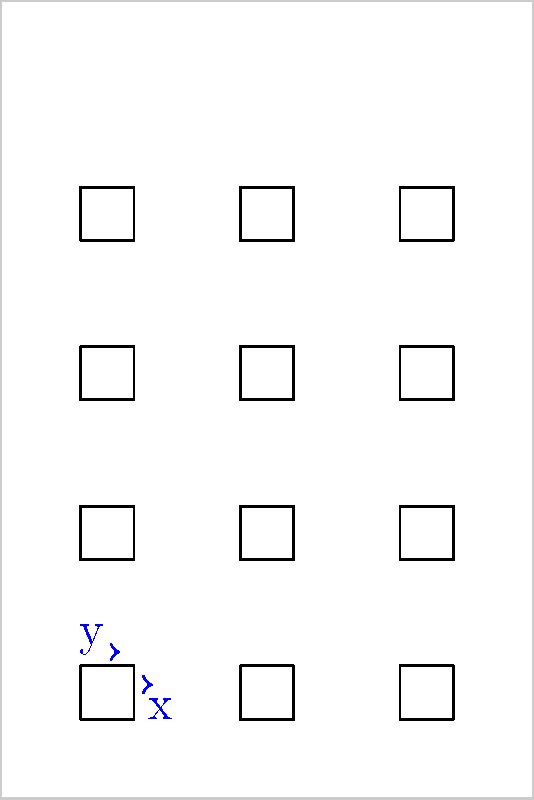A standard sheet measures 10 inches wide by 15 inches tall. You need to print 12 square labels, each measuring 1 inch by 1 inch, arranged in a 3x4 grid. What should be the horizontal (x) and vertical (y) spacing between the labels to ensure equal margins on all sides of the sheet? Let's approach this step-by-step:

1) First, let's calculate the total width occupied by the labels:
   3 labels × 1 inch = 3 inches

2) The remaining width for margins and spacing:
   10 inches - 3 inches = 7 inches

3) This 7 inches needs to be divided into 4 equal parts (2 outer margins and 2 spaces between labels):
   7 inches ÷ 4 = 1.75 inches

4) Therefore, the horizontal spacing (x) between labels is 1.75 inches.

5) Now, let's calculate the total height occupied by the labels:
   4 labels × 1 inch = 4 inches

6) The remaining height for margins and spacing:
   15 inches - 4 inches = 11 inches

7) This 11 inches needs to be divided into 5 equal parts (2 outer margins and 3 spaces between labels):
   11 inches ÷ 5 = 2.2 inches

8) Therefore, the vertical spacing (y) between labels is 2.2 inches.
Answer: x = 1.75 inches, y = 2.2 inches 